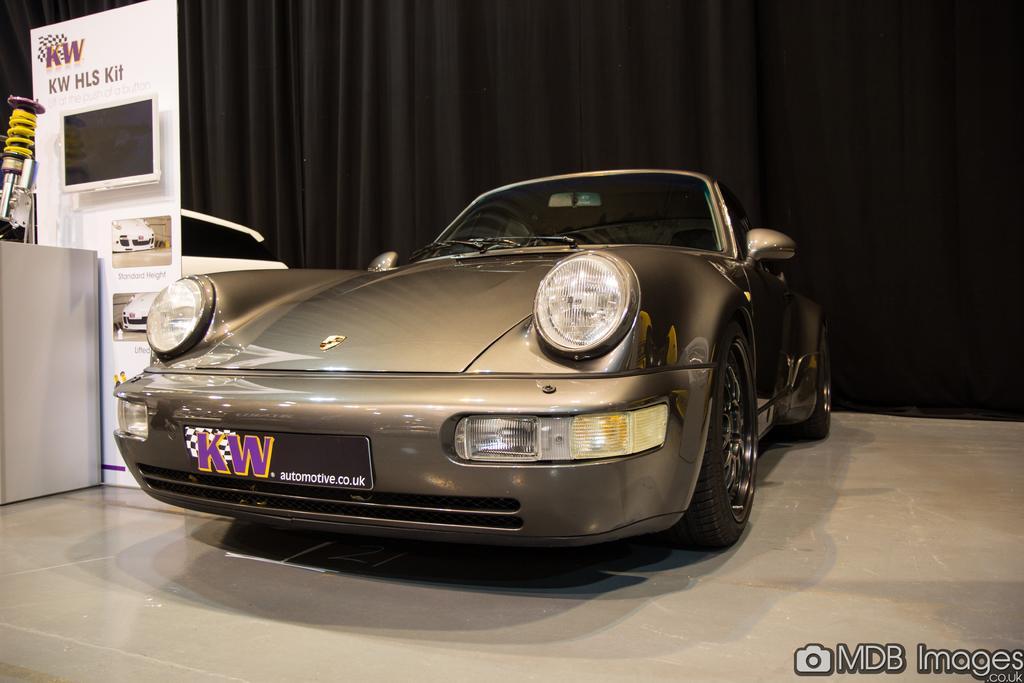Please provide a concise description of this image. In this image I can see the floor, a car on the floor and in the background I can see the black colored curtain, a white colored board, a television screen to the board and few other objects. 